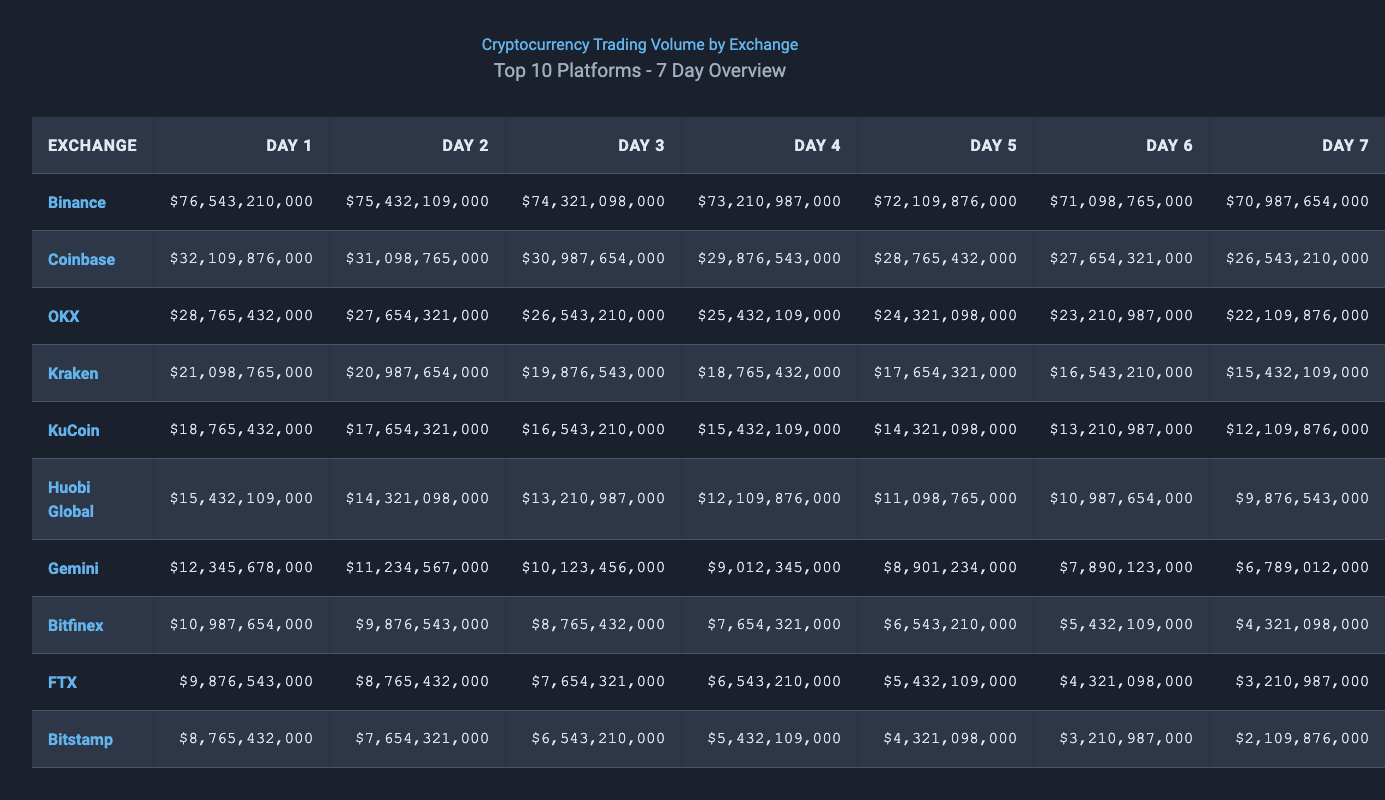What is the trading volume for Binance on Day 1? The table lists the trading volumes for all exchanges on Day 1. For Binance, the trading volume is shown as $76,543,210,000.
Answer: $76,543,210,000 Which exchange had the lowest trading volume on Day 7? In the table, looking at the trading volumes for Day 7, the lowest trading volume is for Bitstamp, which is $2,109,876,000.
Answer: $2,109,876,000 What is the total trading volume for Coinbase across all seven days? To find the total for Coinbase, sum the trading volumes across all days: $32,109,876,000 + $31,098,765,000 + $30,987,654,000 + $29,876,543,000 + $28,765,432,000 + $27,654,321,000 + $26,543,210,000 = $205,129,730,000.
Answer: $205,129,730,000 Is the trading volume for Kraken on Day 4 greater than the volume for KuCoin on Day 3? Comparing the two values: Kraken on Day 4 is $18,765,432,000, and KuCoin on Day 3 is $24,321,098,000. Since $18,765,432,000 is less than $24,321,098,000, the answer is no.
Answer: No Which exchange had the highest trading volume on Day 5? By examining the Day 5 column, Binance has the highest trading volume at $72,109,876,000 compared to other exchanges.
Answer: Binance What is the average trading volume for Huobi Global over the seven days? For Huobi Global: Total = $15,432,109,000 + $14,321,098,000 + $13,210,987,000 + $12,109,876,000 + $11,098,765,000 + $10,987,654,000 + $9,876,543,000 = $96,042,932,000. Average = $96,042,932,000 / 7 ≈ $13,720,418,857.
Answer: $13,720,418,857 Which exchange had a consistent decrease in trading volume over the seven days? Observing the table, Bitstamp shows a consistent decrease from $8,765,432,000 on Day 1 to $2,109,876,000 on Day 7.
Answer: Bitstamp What was the combined trading volume for the top three exchanges on Day 2? For Day 2, the top three exchanges are Binance: $32,109,876,000, Coinbase: $31,098,765,000, and OKX: $30,987,654,000. Combined total = $32,109,876,000 + $31,098,765,000 + $30,987,654,000 = $94,196,295,000.
Answer: $94,196,295,000 Did Gemini's trading volume increase from Day 1 to Day 3? Day 1 volume for Gemini is $12,345,678,000, and Day 3 volume is $10,123,456,000. Since $12,345,678,000 is greater, the volume did not increase.
Answer: No What is the difference in trading volume between OKX on Day 4 and Day 6? For OKX, Day 4 volume is $21,098,765,000, and Day 6 volume is $23,210,987,000. The difference is $23,210,987,000 - $21,098,765,000 = $2,112,222,000.
Answer: $2,112,222,000 